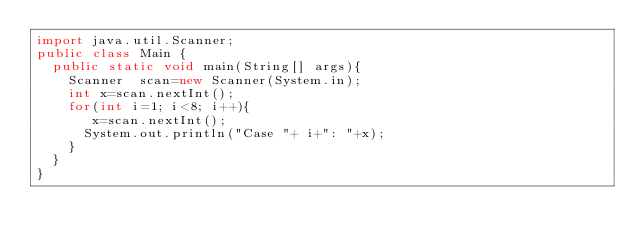<code> <loc_0><loc_0><loc_500><loc_500><_Java_>import java.util.Scanner;
public class Main {
	public static void main(String[] args){
		Scanner  scan=new Scanner(System.in);
		int x=scan.nextInt();
		for(int i=1; i<8; i++){
			 x=scan.nextInt();
			System.out.println("Case "+ i+": "+x);
		}
	}
}

</code> 